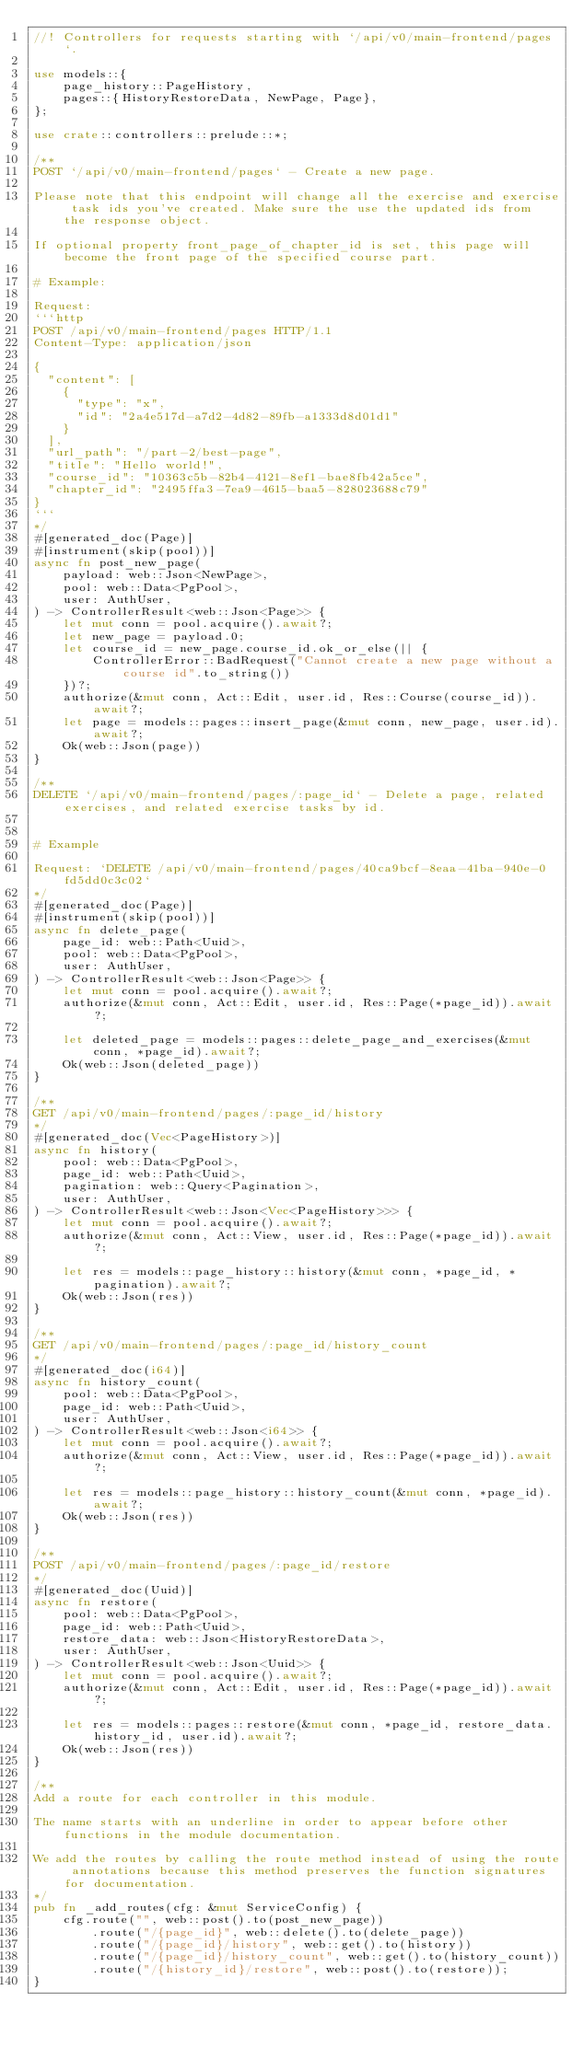Convert code to text. <code><loc_0><loc_0><loc_500><loc_500><_Rust_>//! Controllers for requests starting with `/api/v0/main-frontend/pages`.

use models::{
    page_history::PageHistory,
    pages::{HistoryRestoreData, NewPage, Page},
};

use crate::controllers::prelude::*;

/**
POST `/api/v0/main-frontend/pages` - Create a new page.

Please note that this endpoint will change all the exercise and exercise task ids you've created. Make sure the use the updated ids from the response object.

If optional property front_page_of_chapter_id is set, this page will become the front page of the specified course part.

# Example:

Request:
```http
POST /api/v0/main-frontend/pages HTTP/1.1
Content-Type: application/json

{
  "content": [
    {
      "type": "x",
      "id": "2a4e517d-a7d2-4d82-89fb-a1333d8d01d1"
    }
  ],
  "url_path": "/part-2/best-page",
  "title": "Hello world!",
  "course_id": "10363c5b-82b4-4121-8ef1-bae8fb42a5ce",
  "chapter_id": "2495ffa3-7ea9-4615-baa5-828023688c79"
}
```
*/
#[generated_doc(Page)]
#[instrument(skip(pool))]
async fn post_new_page(
    payload: web::Json<NewPage>,
    pool: web::Data<PgPool>,
    user: AuthUser,
) -> ControllerResult<web::Json<Page>> {
    let mut conn = pool.acquire().await?;
    let new_page = payload.0;
    let course_id = new_page.course_id.ok_or_else(|| {
        ControllerError::BadRequest("Cannot create a new page without a course id".to_string())
    })?;
    authorize(&mut conn, Act::Edit, user.id, Res::Course(course_id)).await?;
    let page = models::pages::insert_page(&mut conn, new_page, user.id).await?;
    Ok(web::Json(page))
}

/**
DELETE `/api/v0/main-frontend/pages/:page_id` - Delete a page, related exercises, and related exercise tasks by id.


# Example

Request: `DELETE /api/v0/main-frontend/pages/40ca9bcf-8eaa-41ba-940e-0fd5dd0c3c02`
*/
#[generated_doc(Page)]
#[instrument(skip(pool))]
async fn delete_page(
    page_id: web::Path<Uuid>,
    pool: web::Data<PgPool>,
    user: AuthUser,
) -> ControllerResult<web::Json<Page>> {
    let mut conn = pool.acquire().await?;
    authorize(&mut conn, Act::Edit, user.id, Res::Page(*page_id)).await?;

    let deleted_page = models::pages::delete_page_and_exercises(&mut conn, *page_id).await?;
    Ok(web::Json(deleted_page))
}

/**
GET /api/v0/main-frontend/pages/:page_id/history
*/
#[generated_doc(Vec<PageHistory>)]
async fn history(
    pool: web::Data<PgPool>,
    page_id: web::Path<Uuid>,
    pagination: web::Query<Pagination>,
    user: AuthUser,
) -> ControllerResult<web::Json<Vec<PageHistory>>> {
    let mut conn = pool.acquire().await?;
    authorize(&mut conn, Act::View, user.id, Res::Page(*page_id)).await?;

    let res = models::page_history::history(&mut conn, *page_id, *pagination).await?;
    Ok(web::Json(res))
}

/**
GET /api/v0/main-frontend/pages/:page_id/history_count
*/
#[generated_doc(i64)]
async fn history_count(
    pool: web::Data<PgPool>,
    page_id: web::Path<Uuid>,
    user: AuthUser,
) -> ControllerResult<web::Json<i64>> {
    let mut conn = pool.acquire().await?;
    authorize(&mut conn, Act::View, user.id, Res::Page(*page_id)).await?;

    let res = models::page_history::history_count(&mut conn, *page_id).await?;
    Ok(web::Json(res))
}

/**
POST /api/v0/main-frontend/pages/:page_id/restore
*/
#[generated_doc(Uuid)]
async fn restore(
    pool: web::Data<PgPool>,
    page_id: web::Path<Uuid>,
    restore_data: web::Json<HistoryRestoreData>,
    user: AuthUser,
) -> ControllerResult<web::Json<Uuid>> {
    let mut conn = pool.acquire().await?;
    authorize(&mut conn, Act::Edit, user.id, Res::Page(*page_id)).await?;

    let res = models::pages::restore(&mut conn, *page_id, restore_data.history_id, user.id).await?;
    Ok(web::Json(res))
}

/**
Add a route for each controller in this module.

The name starts with an underline in order to appear before other functions in the module documentation.

We add the routes by calling the route method instead of using the route annotations because this method preserves the function signatures for documentation.
*/
pub fn _add_routes(cfg: &mut ServiceConfig) {
    cfg.route("", web::post().to(post_new_page))
        .route("/{page_id}", web::delete().to(delete_page))
        .route("/{page_id}/history", web::get().to(history))
        .route("/{page_id}/history_count", web::get().to(history_count))
        .route("/{history_id}/restore", web::post().to(restore));
}
</code> 